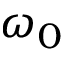Convert formula to latex. <formula><loc_0><loc_0><loc_500><loc_500>\omega _ { 0 }</formula> 